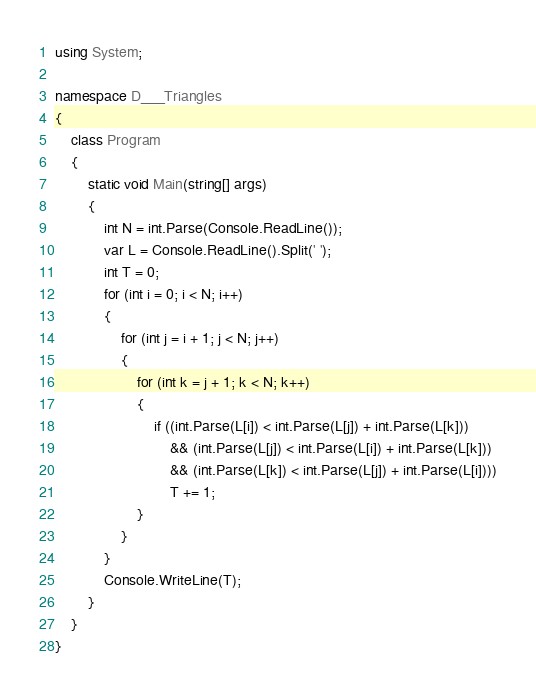Convert code to text. <code><loc_0><loc_0><loc_500><loc_500><_C#_>using System;

namespace D___Triangles
{
    class Program
    {
        static void Main(string[] args)
        {
            int N = int.Parse(Console.ReadLine());
            var L = Console.ReadLine().Split(' ');
            int T = 0;
            for (int i = 0; i < N; i++)
            {
                for (int j = i + 1; j < N; j++)
                {
                    for (int k = j + 1; k < N; k++)
                    {
                        if ((int.Parse(L[i]) < int.Parse(L[j]) + int.Parse(L[k]))
                            && (int.Parse(L[j]) < int.Parse(L[i]) + int.Parse(L[k]))
                            && (int.Parse(L[k]) < int.Parse(L[j]) + int.Parse(L[i])))
                            T += 1;
                    }
                }
            }
            Console.WriteLine(T);
        }
    }
}</code> 